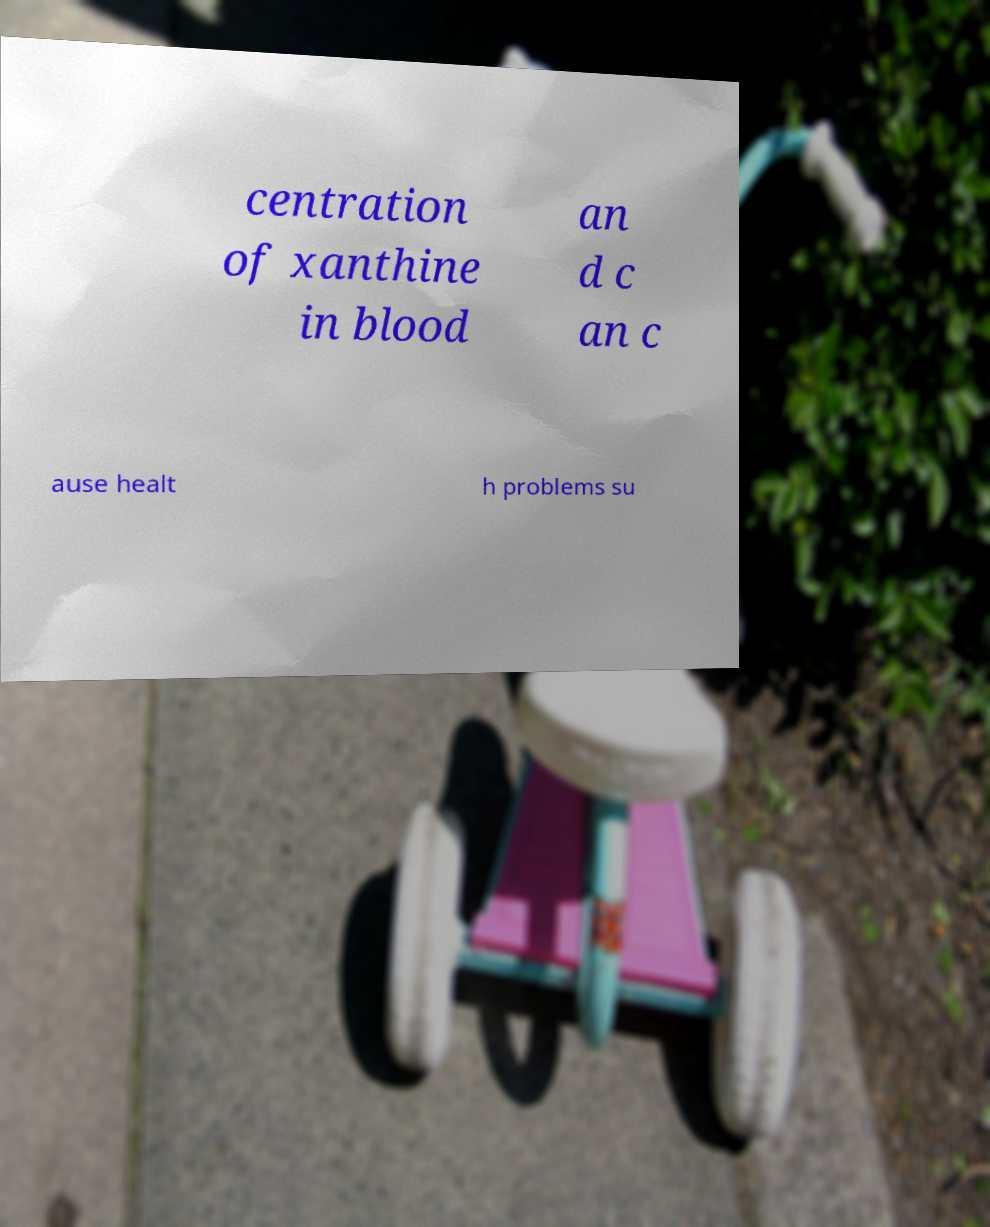What messages or text are displayed in this image? I need them in a readable, typed format. centration of xanthine in blood an d c an c ause healt h problems su 